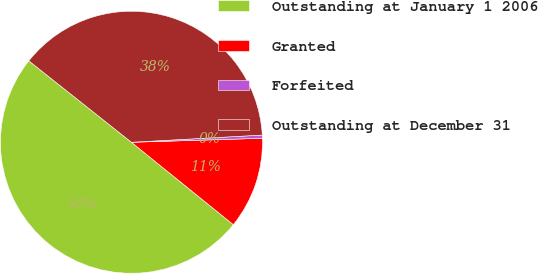Convert chart. <chart><loc_0><loc_0><loc_500><loc_500><pie_chart><fcel>Outstanding at January 1 2006<fcel>Granted<fcel>Forfeited<fcel>Outstanding at December 31<nl><fcel>49.85%<fcel>11.31%<fcel>0.39%<fcel>38.45%<nl></chart> 